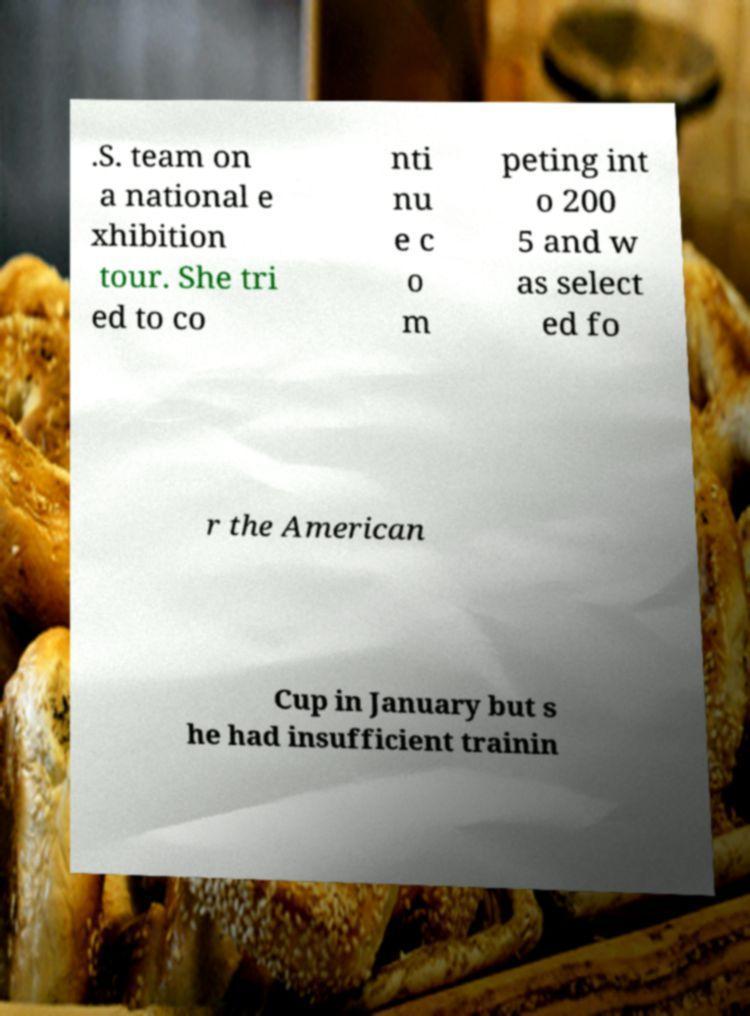Please identify and transcribe the text found in this image. .S. team on a national e xhibition tour. She tri ed to co nti nu e c o m peting int o 200 5 and w as select ed fo r the American Cup in January but s he had insufficient trainin 